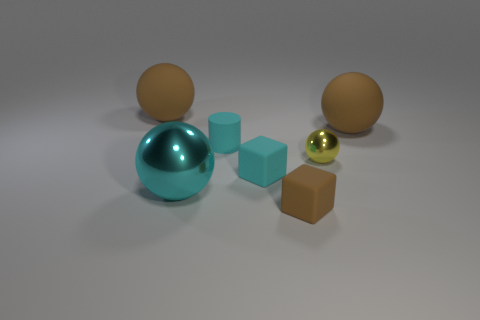There is a big brown object that is right of the brown block; what material is it? The big brown object to the right of the brown block appears to be made of a matte-finish plastic, characterized by its smooth surface and the way it diffusely reflects light. 